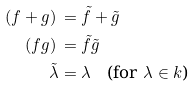Convert formula to latex. <formula><loc_0><loc_0><loc_500><loc_500>( f + g ) \, & = \tilde { f } + \tilde { g } \\ ( f g ) \, & = \tilde { f } \tilde { g } \\ \tilde { \lambda } & = \lambda \quad \text {(for $\lambda\in k$)}</formula> 